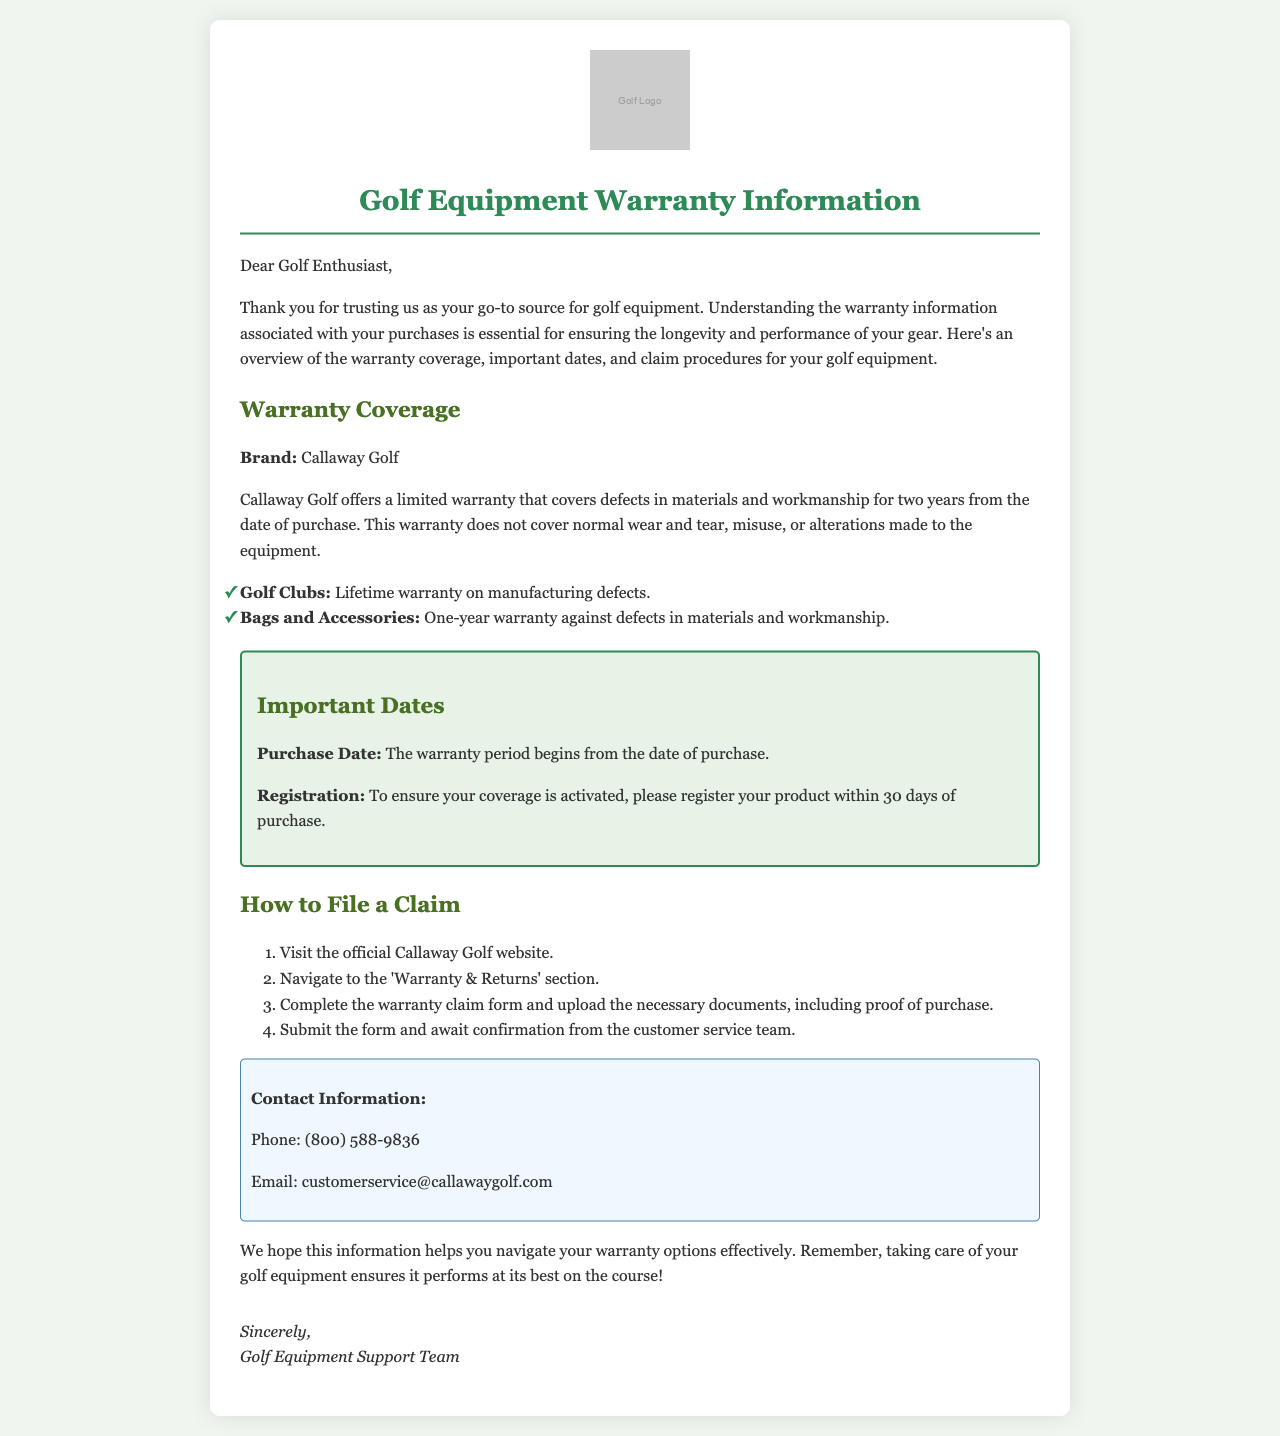What is the warranty duration for golf clubs? The warranty duration for golf clubs is a lifetime warranty on manufacturing defects.
Answer: Lifetime warranty What is the contact phone number for Callaway Golf? The contact phone number for Callaway Golf is provided in the contact information section.
Answer: (800) 588-9836 What must you do within 30 days of purchase? This refers to the requirement to ensure warranty coverage activation.
Answer: Register your product What is not covered by the warranty? This question seeks information on the limitations of the warranty based on the document's warranty coverage details.
Answer: Normal wear and tear How many years does the warranty cover bags and accessories? The document specifies the duration of warranty coverage for bags and accessories.
Answer: One year Where can you find the warranty claim form? The question asks about the location of the warranty claim form as mentioned in the claim process.
Answer: Official Callaway Golf website What type of warranty is provided for bags and accessories? This question focuses on the type of warranty coverage mentioned in the document for those items.
Answer: One-year warranty Who is the document addressed to? This question identifies the target audience of the letter based on the greeting.
Answer: Golf Enthusiast 